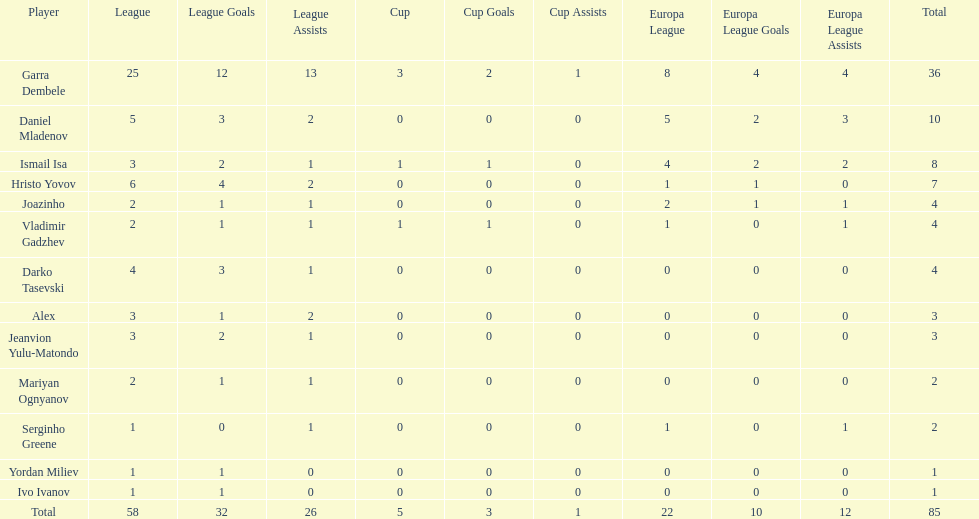Which players have at least 4 in the europa league? Garra Dembele, Daniel Mladenov, Ismail Isa. 